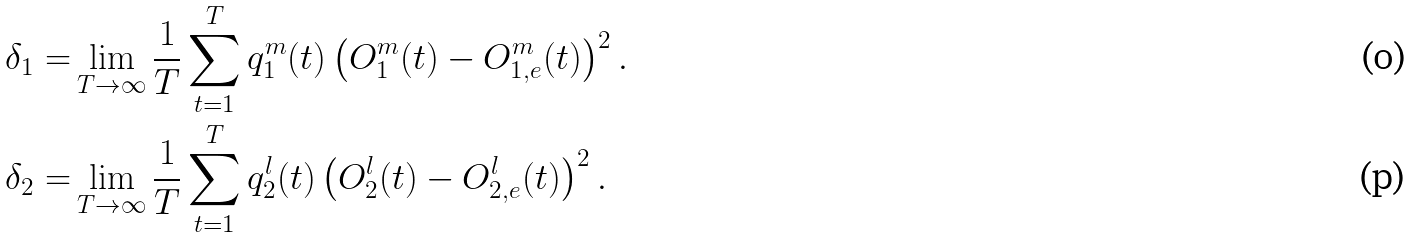<formula> <loc_0><loc_0><loc_500><loc_500>\delta _ { 1 } = & \lim _ { T \to \infty } \frac { 1 } { T } \sum _ { t = 1 } ^ { T } q _ { 1 } ^ { m } ( t ) \left ( O _ { 1 } ^ { m } ( t ) - O _ { 1 , e } ^ { m } ( t ) \right ) ^ { 2 } . \\ \delta _ { 2 } = & \lim _ { T \to \infty } \frac { 1 } { T } \sum _ { t = 1 } ^ { T } q _ { 2 } ^ { l } ( t ) \left ( O _ { 2 } ^ { l } ( t ) - O _ { 2 , e } ^ { l } ( t ) \right ) ^ { 2 } .</formula> 